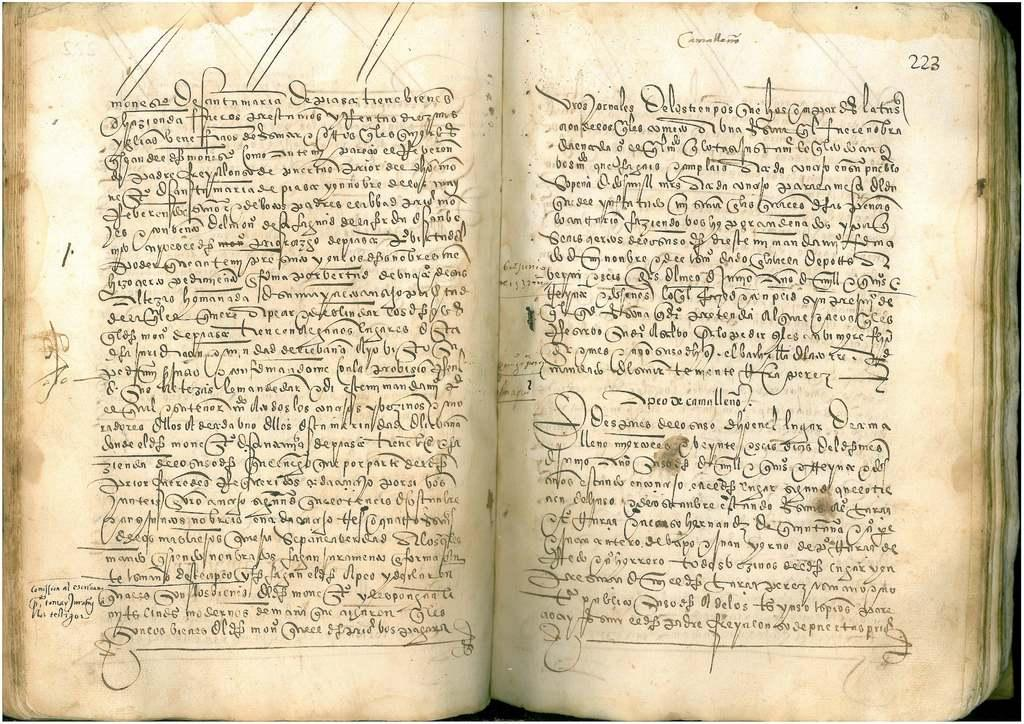<image>
Give a short and clear explanation of the subsequent image. An old book with fancy writing is open to page 223. 